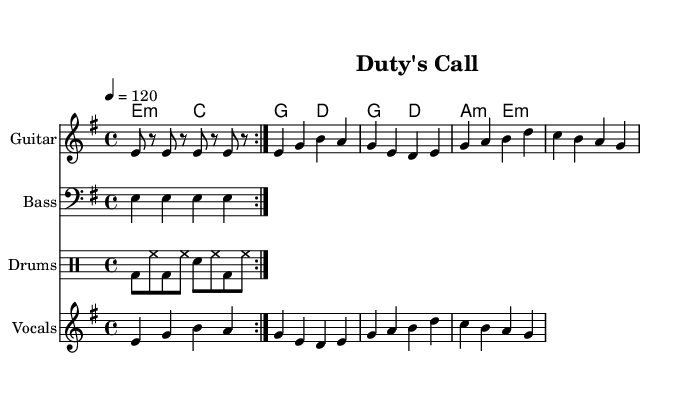What is the key signature of this music? The key signature is E minor, which has one sharp (F#).
Answer: E minor What is the time signature of the piece? The time signature shown in the music sheet is 4/4, meaning there are four beats per measure.
Answer: 4/4 What is the tempo marking for the music? The tempo marking is four equals 120, indicating a moderate speed for the piece.
Answer: 120 How many measures are in the verse section? The verse section includes a total of four measures, as seen in the notation provided.
Answer: 4 Which chord is played in the chorus along with the first measure? The first measure of the chorus has a G major chord played.
Answer: G What are the lyrics of the first line in the verse? The first line of the verse lyrics as shown in the music sheet is "In the shadows we stand tall."
Answer: "In the shadows we stand tall." How many instruments are used in this piece? The sheet music indicates that there are four instruments: guitar, bass, drums, and vocals.
Answer: 4 